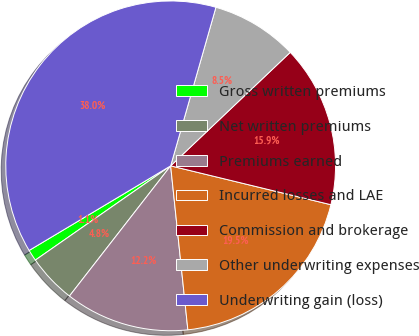<chart> <loc_0><loc_0><loc_500><loc_500><pie_chart><fcel>Gross written premiums<fcel>Net written premiums<fcel>Premiums earned<fcel>Incurred losses and LAE<fcel>Commission and brokerage<fcel>Other underwriting expenses<fcel>Underwriting gain (loss)<nl><fcel>1.11%<fcel>4.8%<fcel>12.18%<fcel>19.55%<fcel>15.87%<fcel>8.49%<fcel>38.0%<nl></chart> 